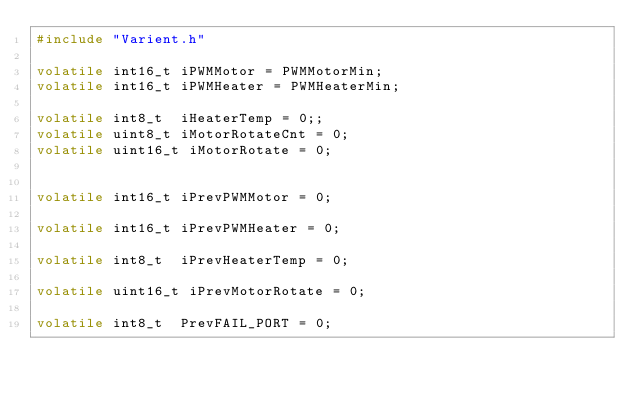Convert code to text. <code><loc_0><loc_0><loc_500><loc_500><_C_>#include "Varient.h"

volatile int16_t iPWMMotor = PWMMotorMin; 
volatile int16_t iPWMHeater = PWMHeaterMin;

volatile int8_t  iHeaterTemp = 0;;
volatile uint8_t iMotorRotateCnt = 0; 
volatile uint16_t iMotorRotate = 0;


volatile int16_t iPrevPWMMotor = 0;

volatile int16_t iPrevPWMHeater = 0; 

volatile int8_t  iPrevHeaterTemp = 0;

volatile uint16_t iPrevMotorRotate = 0;

volatile int8_t  PrevFAIL_PORT = 0;
</code> 